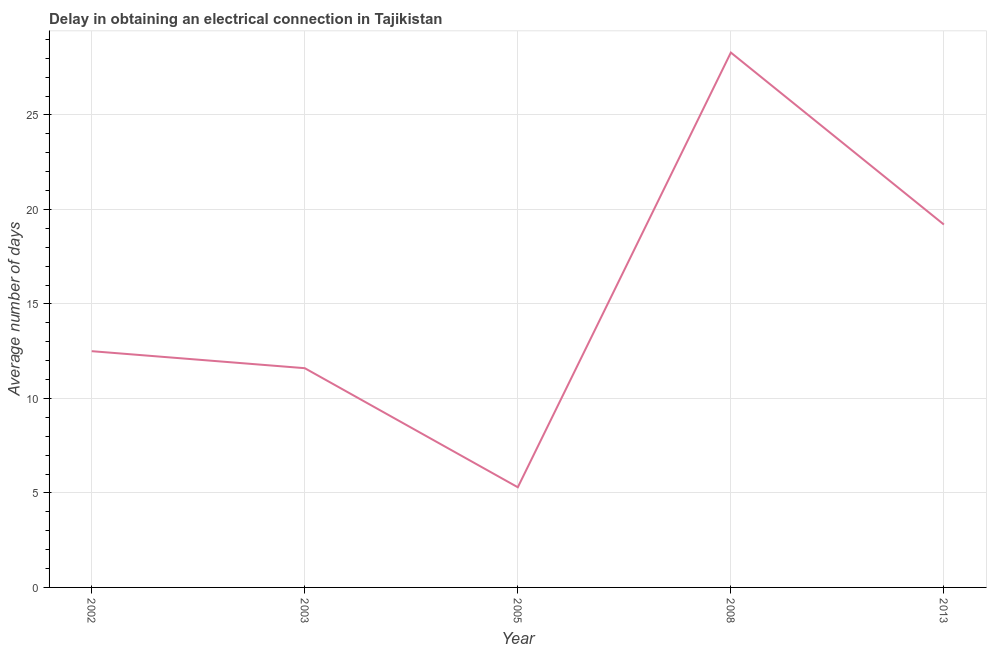Across all years, what is the maximum dalay in electrical connection?
Ensure brevity in your answer.  28.3. What is the sum of the dalay in electrical connection?
Give a very brief answer. 76.9. What is the difference between the dalay in electrical connection in 2008 and 2013?
Ensure brevity in your answer.  9.1. What is the average dalay in electrical connection per year?
Provide a short and direct response. 15.38. What is the median dalay in electrical connection?
Keep it short and to the point. 12.5. What is the ratio of the dalay in electrical connection in 2002 to that in 2008?
Offer a very short reply. 0.44. Is the dalay in electrical connection in 2002 less than that in 2008?
Your answer should be very brief. Yes. Is the difference between the dalay in electrical connection in 2005 and 2008 greater than the difference between any two years?
Your answer should be compact. Yes. What is the difference between the highest and the second highest dalay in electrical connection?
Offer a terse response. 9.1. In how many years, is the dalay in electrical connection greater than the average dalay in electrical connection taken over all years?
Offer a terse response. 2. Does the dalay in electrical connection monotonically increase over the years?
Offer a very short reply. No. How many lines are there?
Keep it short and to the point. 1. Are the values on the major ticks of Y-axis written in scientific E-notation?
Offer a terse response. No. Does the graph contain any zero values?
Your response must be concise. No. Does the graph contain grids?
Provide a short and direct response. Yes. What is the title of the graph?
Make the answer very short. Delay in obtaining an electrical connection in Tajikistan. What is the label or title of the Y-axis?
Offer a very short reply. Average number of days. What is the Average number of days of 2003?
Offer a very short reply. 11.6. What is the Average number of days in 2005?
Ensure brevity in your answer.  5.3. What is the Average number of days in 2008?
Your response must be concise. 28.3. What is the difference between the Average number of days in 2002 and 2008?
Keep it short and to the point. -15.8. What is the difference between the Average number of days in 2003 and 2008?
Offer a very short reply. -16.7. What is the difference between the Average number of days in 2005 and 2008?
Make the answer very short. -23. What is the difference between the Average number of days in 2005 and 2013?
Keep it short and to the point. -13.9. What is the difference between the Average number of days in 2008 and 2013?
Keep it short and to the point. 9.1. What is the ratio of the Average number of days in 2002 to that in 2003?
Provide a short and direct response. 1.08. What is the ratio of the Average number of days in 2002 to that in 2005?
Your answer should be very brief. 2.36. What is the ratio of the Average number of days in 2002 to that in 2008?
Make the answer very short. 0.44. What is the ratio of the Average number of days in 2002 to that in 2013?
Provide a succinct answer. 0.65. What is the ratio of the Average number of days in 2003 to that in 2005?
Provide a succinct answer. 2.19. What is the ratio of the Average number of days in 2003 to that in 2008?
Offer a terse response. 0.41. What is the ratio of the Average number of days in 2003 to that in 2013?
Offer a terse response. 0.6. What is the ratio of the Average number of days in 2005 to that in 2008?
Provide a short and direct response. 0.19. What is the ratio of the Average number of days in 2005 to that in 2013?
Provide a succinct answer. 0.28. What is the ratio of the Average number of days in 2008 to that in 2013?
Offer a very short reply. 1.47. 